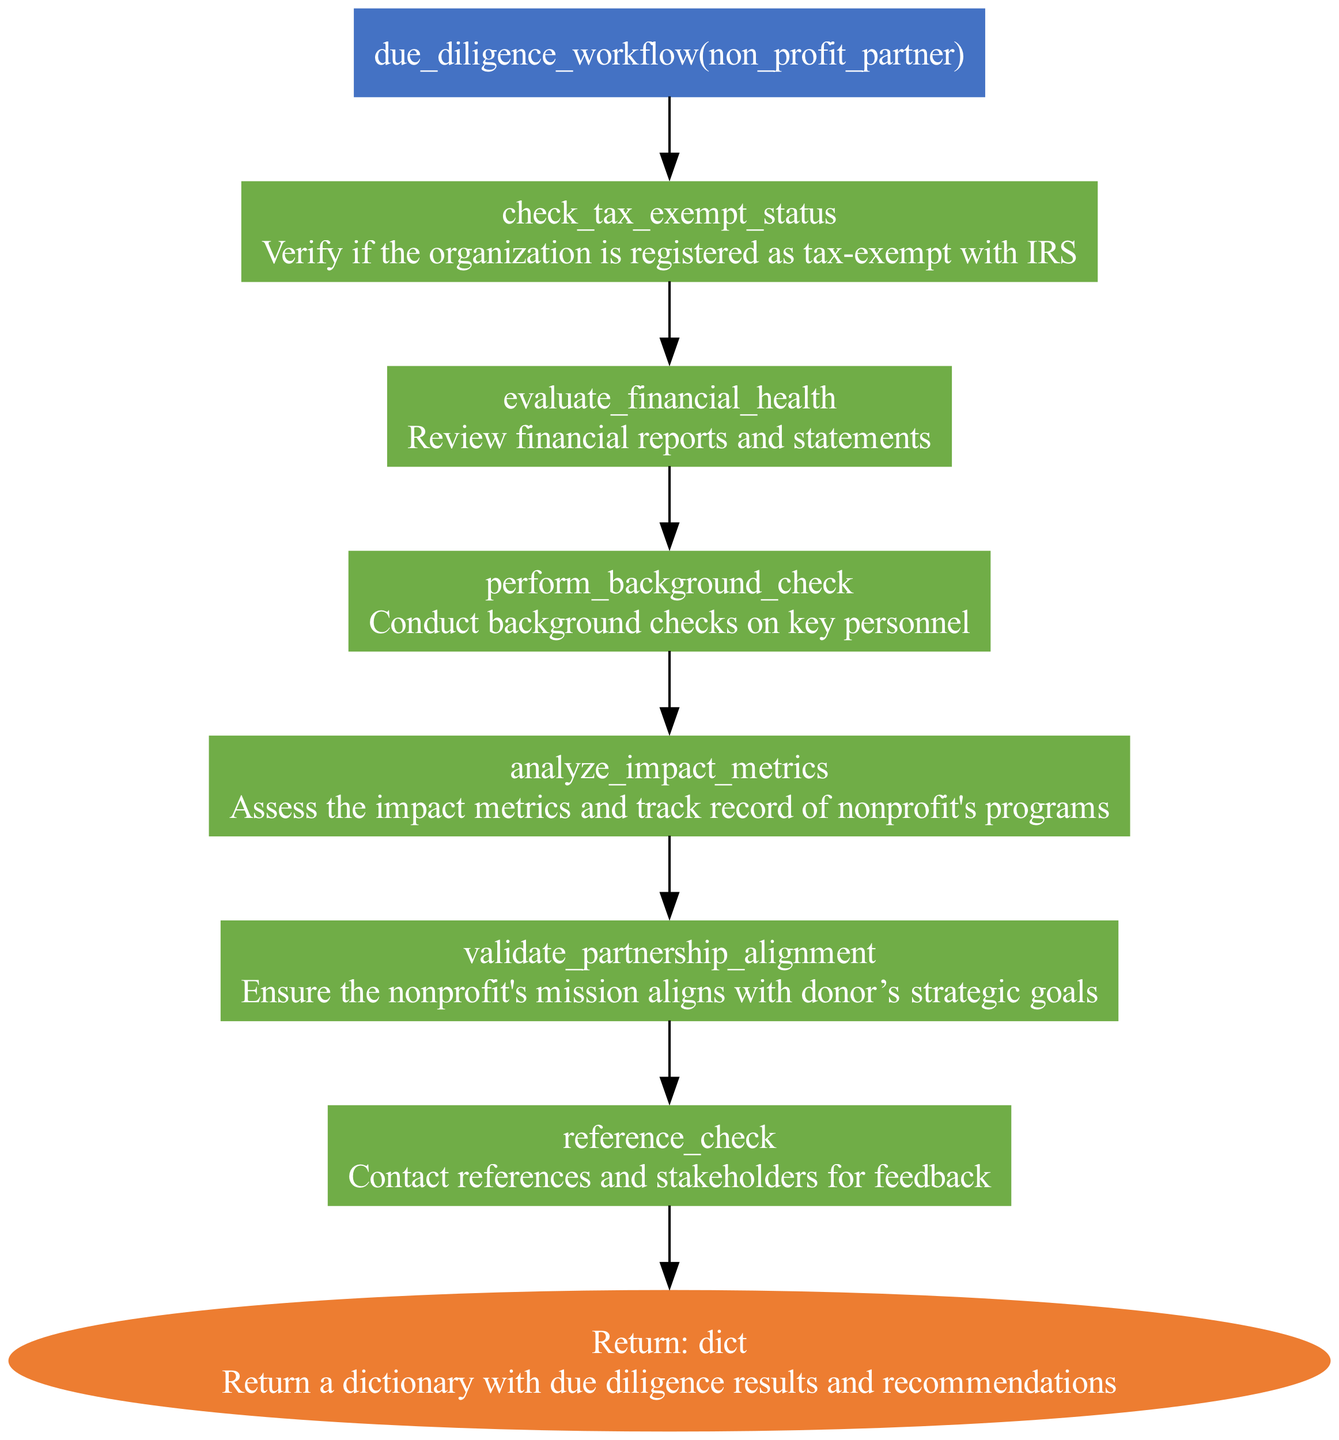What is the first step in the due diligence workflow? The first step is labeled as "check_tax_exempt_status," which focuses on verifying the organization's registration as tax-exempt with the IRS.
Answer: check tax exempt status How many steps are there in the workflow? By counting the number of steps listed between the function and the return node, there are a total of six steps outlined in the workflow.
Answer: six What type of output does the function return? The return type is labeled as "dict," which indicates that the function will return a dictionary containing the due diligence results and recommendations.
Answer: dict What function is called to evaluate the financial health of the nonprofit partner? The specific function called for this step is "review_financial_reports(non_profit_partner)," which assesses the financial health by reviewing relevant reports and statements.
Answer: review financial reports Which step comes after performing a background check? Analyzing the impact metrics follows the step of performing a background check, as indicated by the flow from that step to the next in the diagram.
Answer: analyze impact metrics What is the main focus of the "validate_partnership_alignment" step? This step focuses on ensuring that the nonprofit's mission aligns with the strategic goals of the donor, making it crucial for establishing a successful partnership.
Answer: ensure mission alignment What is the last step before returning the final output? The last step before the return node is "reference_check," which involves contacting references and stakeholders for their feedback on the potential partnership.
Answer: reference check What is the shape of the nodes representing the steps in the diagram? The nodes for each step in the workflow are represented as rectangles, illustrating the process of due diligence clearly.
Answer: rectangle How does the workflow start? The workflow initiates with the function call "due_diligence_workflow(non_profit_partner)," indicating that the process begins with assessing a potential nonprofit partner.
Answer: function call 